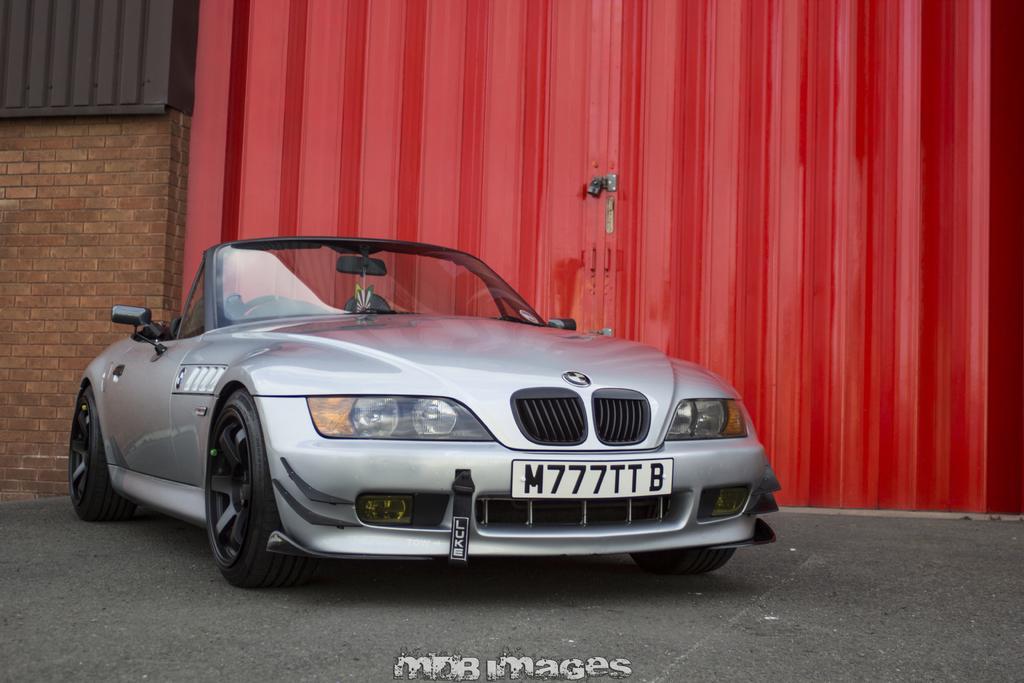Please provide a concise description of this image. In this image, we can see a car in front of the gate. There is a wall on the left side of the image. There is a text at the bottom of the image. 